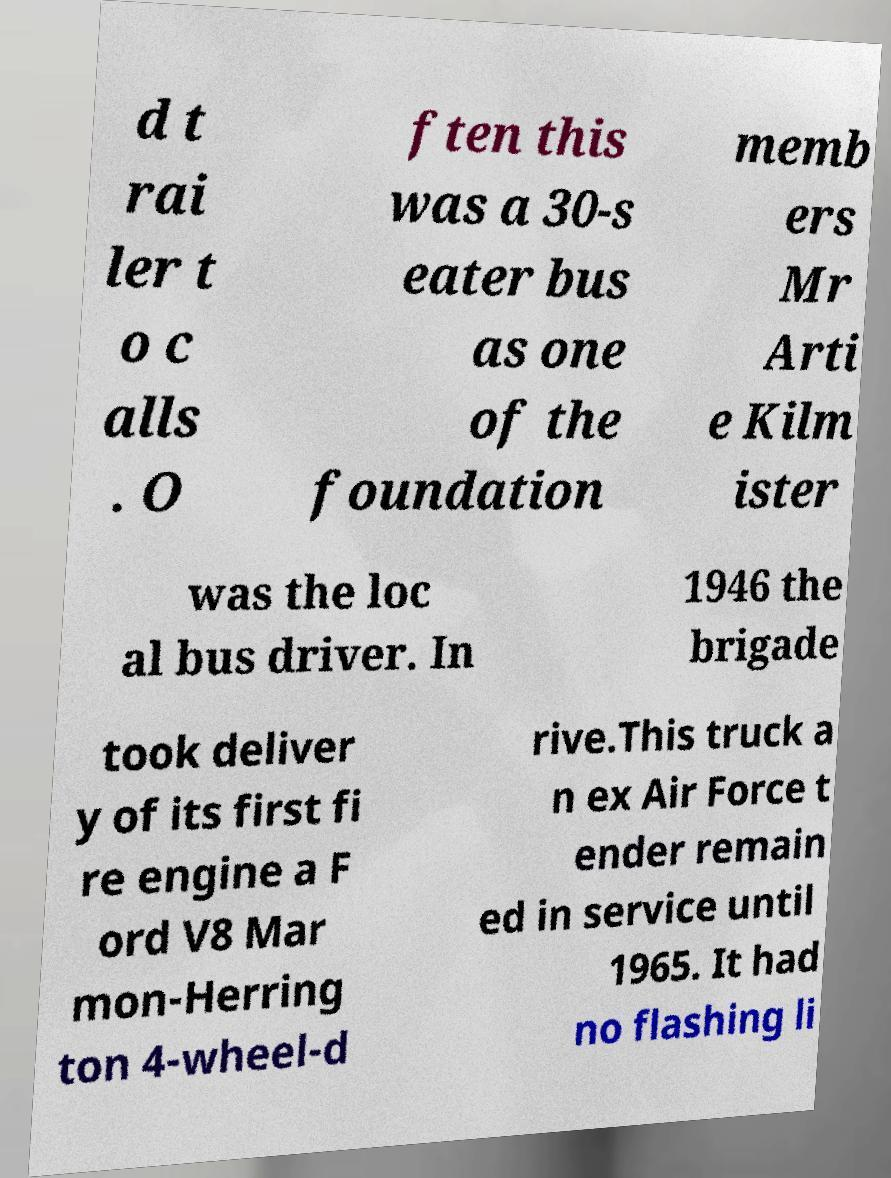What messages or text are displayed in this image? I need them in a readable, typed format. d t rai ler t o c alls . O ften this was a 30-s eater bus as one of the foundation memb ers Mr Arti e Kilm ister was the loc al bus driver. In 1946 the brigade took deliver y of its first fi re engine a F ord V8 Mar mon-Herring ton 4-wheel-d rive.This truck a n ex Air Force t ender remain ed in service until 1965. It had no flashing li 